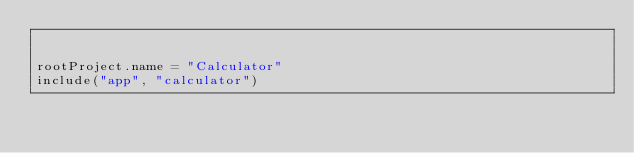Convert code to text. <code><loc_0><loc_0><loc_500><loc_500><_Kotlin_>

rootProject.name = "Calculator"
include("app", "calculator")
</code> 